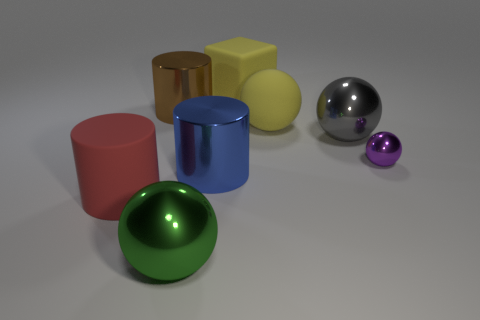Subtract 1 cylinders. How many cylinders are left? 2 Subtract all matte balls. How many balls are left? 3 Subtract all purple balls. How many balls are left? 3 Add 1 brown metallic cylinders. How many objects exist? 9 Subtract all cyan spheres. Subtract all gray cylinders. How many spheres are left? 4 Subtract all blocks. How many objects are left? 7 Add 7 shiny cylinders. How many shiny cylinders are left? 9 Add 6 purple rubber cylinders. How many purple rubber cylinders exist? 6 Subtract 0 green blocks. How many objects are left? 8 Subtract all blocks. Subtract all large green things. How many objects are left? 6 